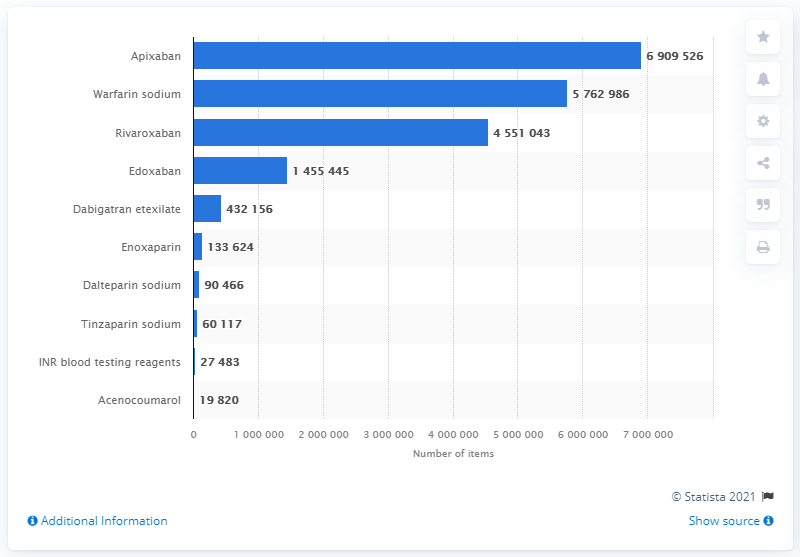Draw attention to some important aspects in this diagram. In 2020, a total of 690,952.6 prescriptions for warfarin sodium were dispensed in England. 